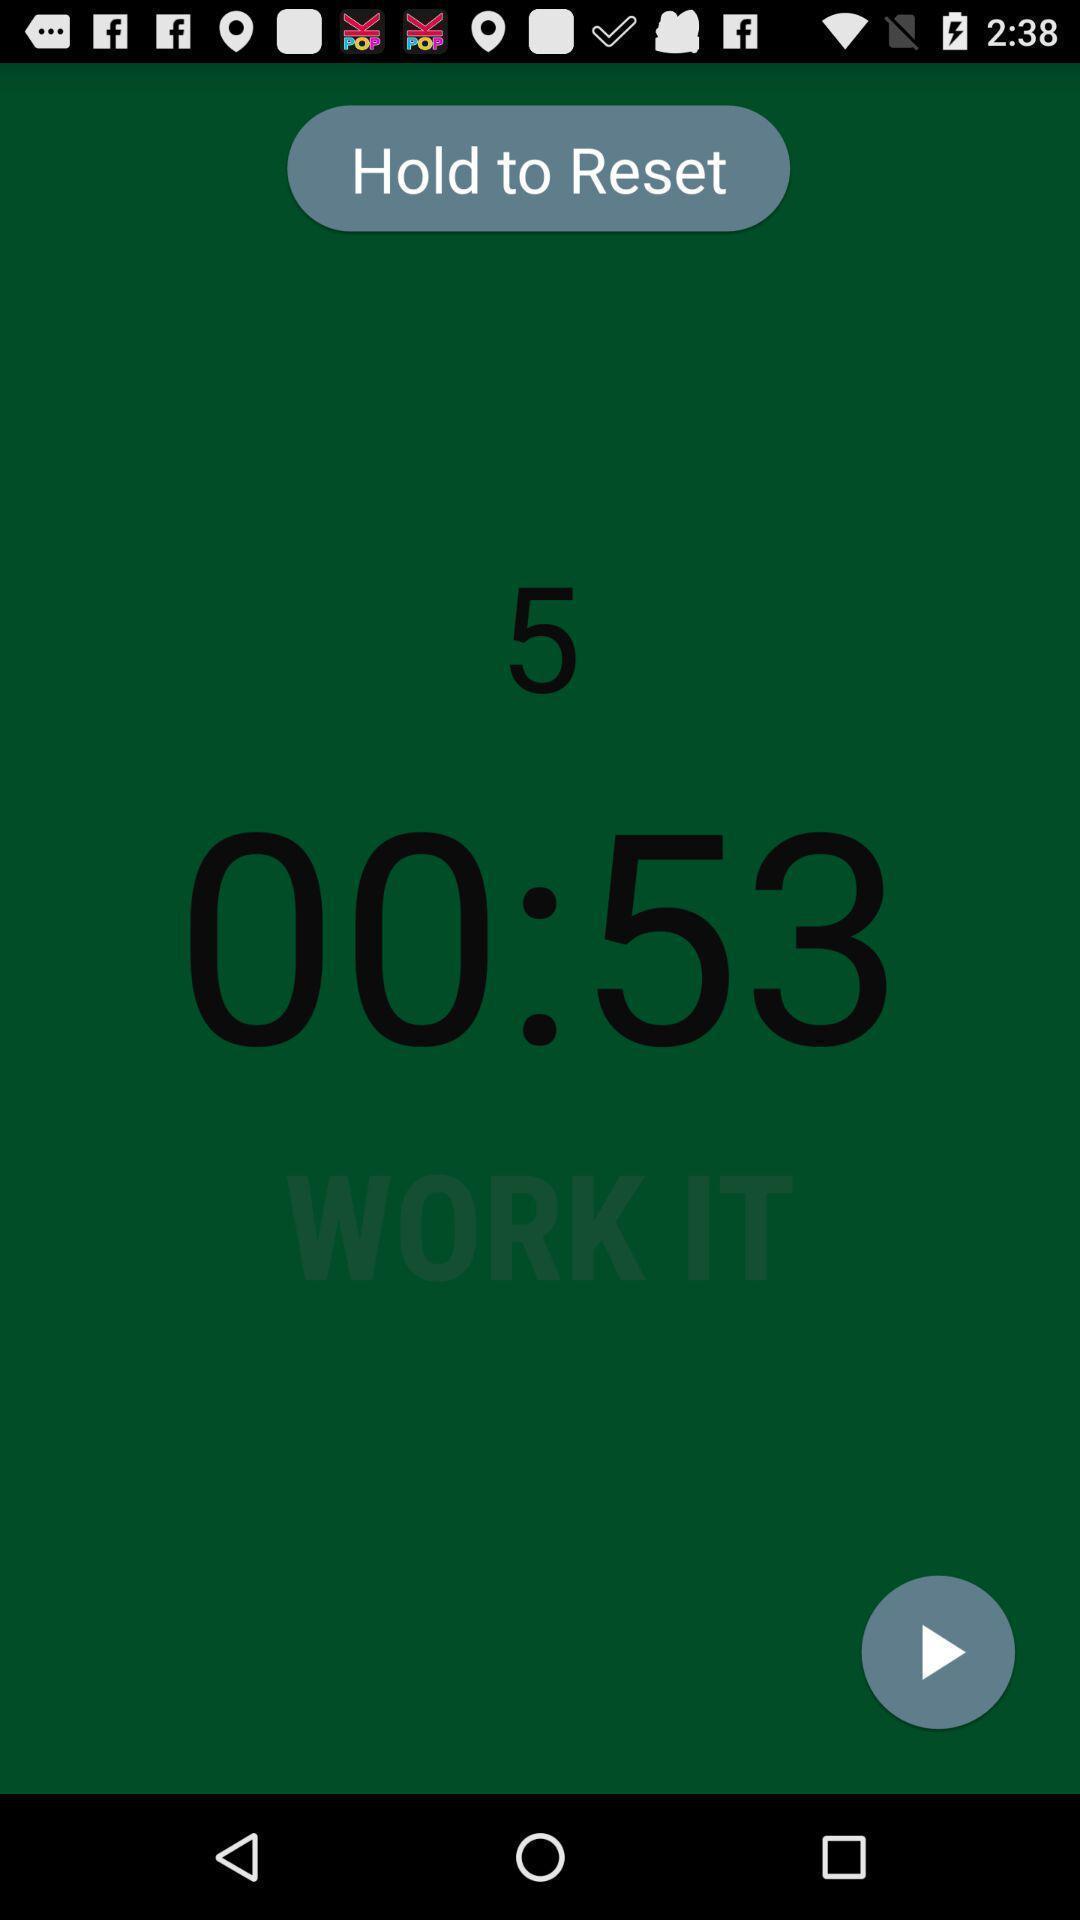Explain the elements present in this screenshot. Stop watch reset notification in app. 